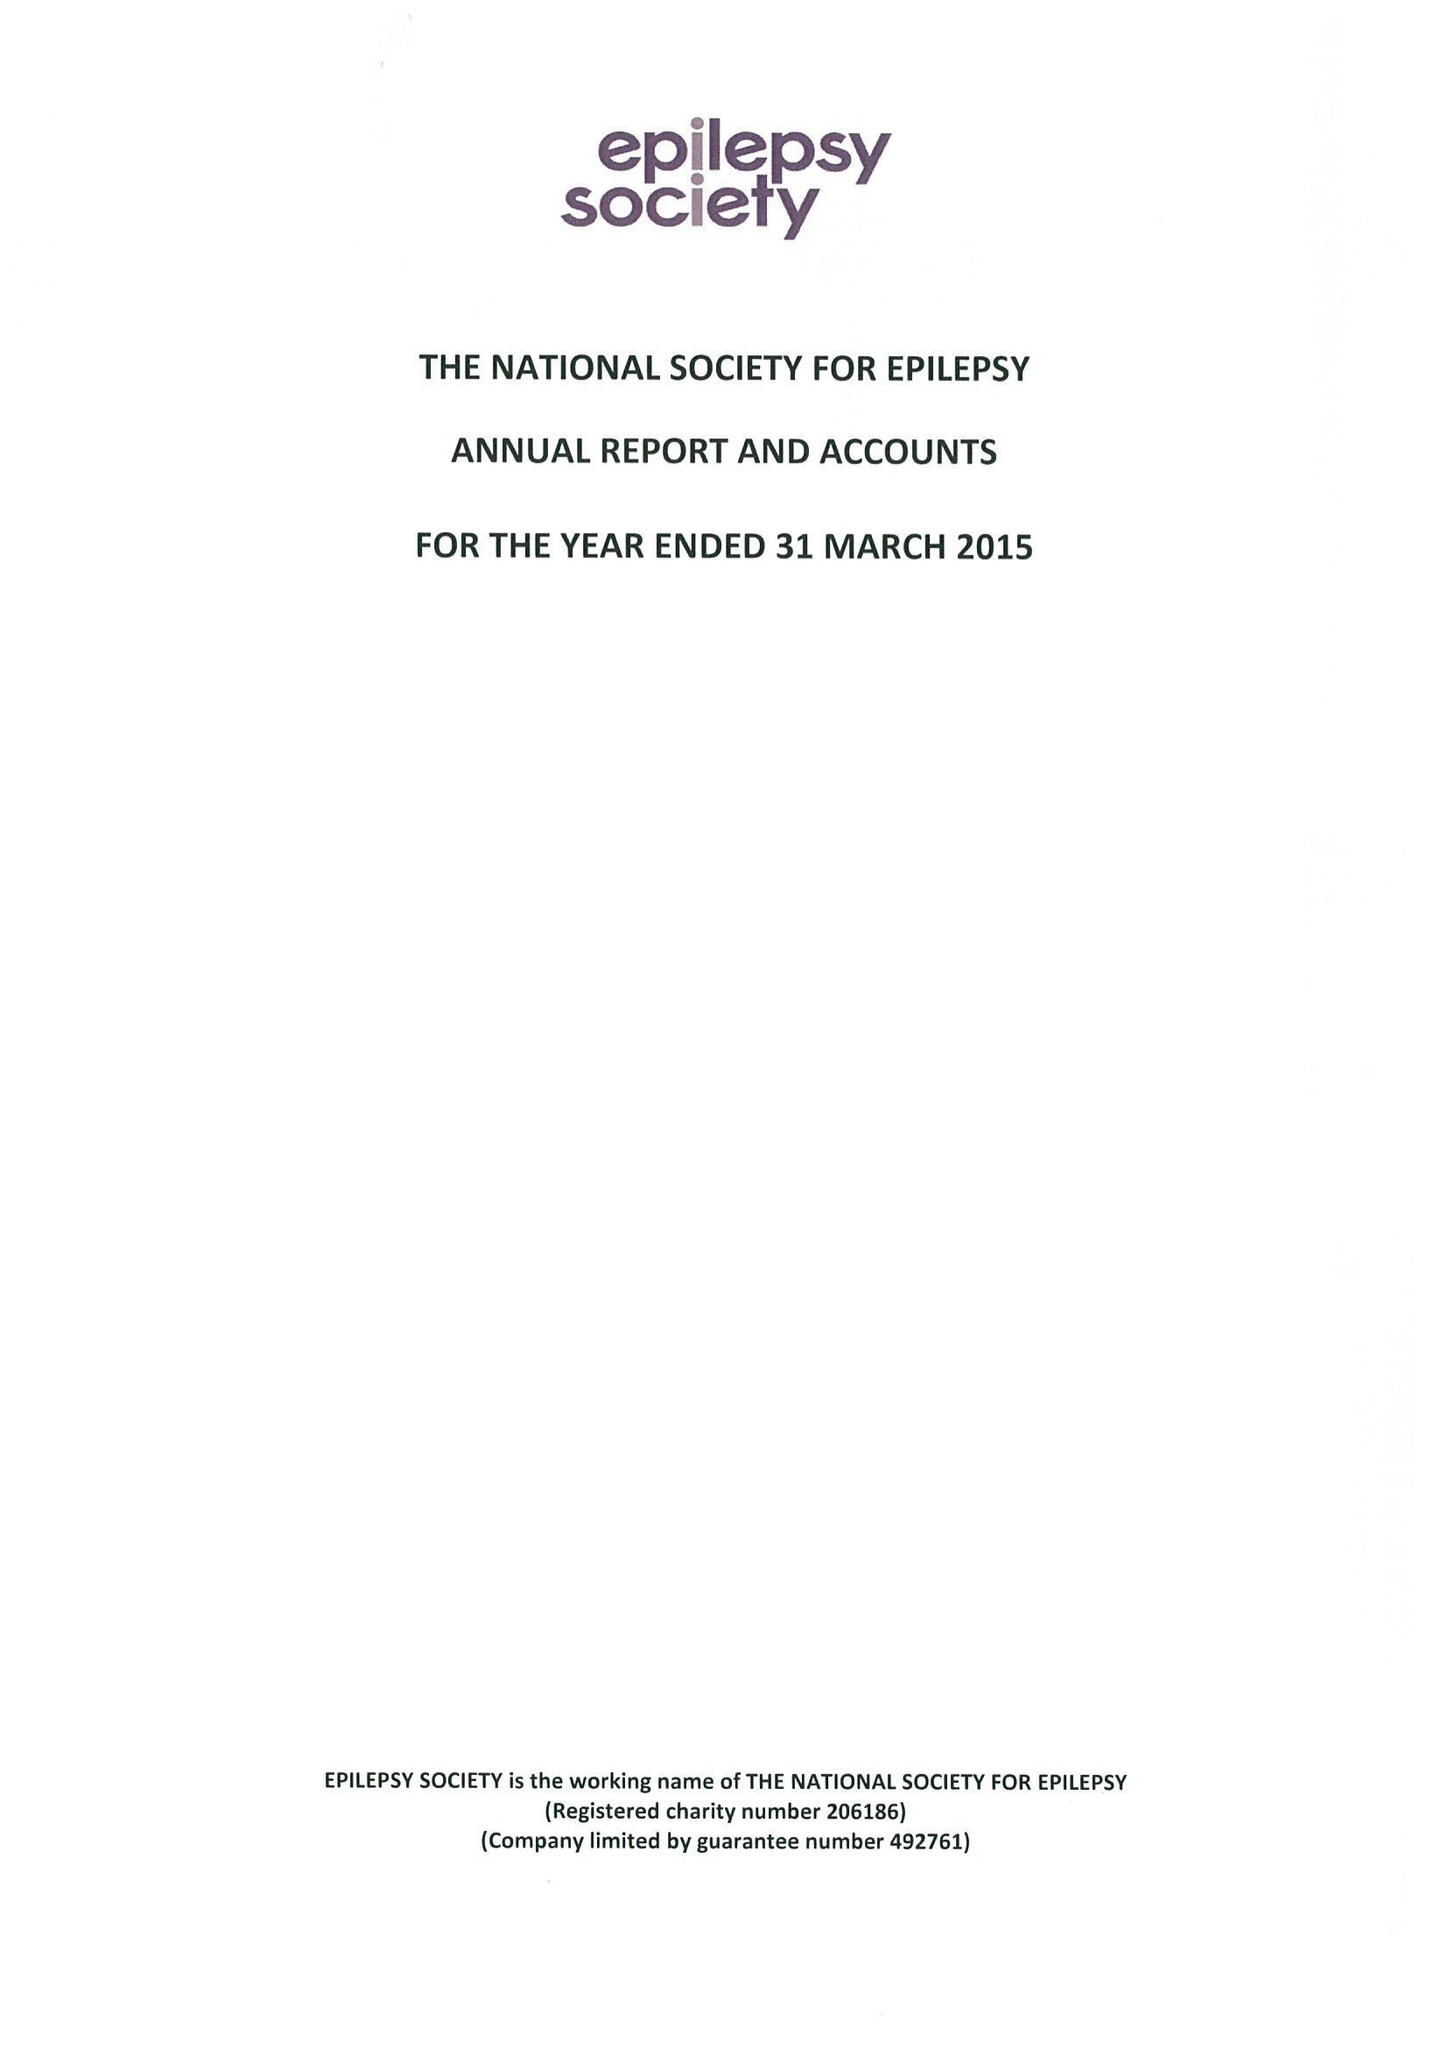What is the value for the spending_annually_in_british_pounds?
Answer the question using a single word or phrase. 16497000.00 